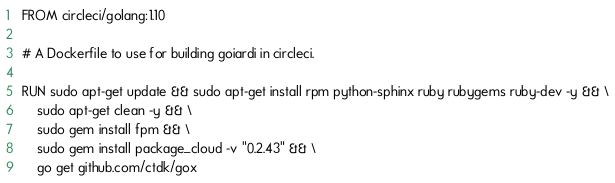Convert code to text. <code><loc_0><loc_0><loc_500><loc_500><_Dockerfile_>FROM circleci/golang:1.10

# A Dockerfile to use for building goiardi in circleci.

RUN sudo apt-get update && sudo apt-get install rpm python-sphinx ruby rubygems ruby-dev -y && \
	sudo apt-get clean -y && \
	sudo gem install fpm && \
	sudo gem install package_cloud -v "0.2.43" && \
	go get github.com/ctdk/gox
</code> 